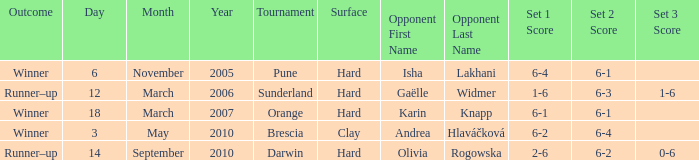What variety of surface was used for the pune contest? Hard. 